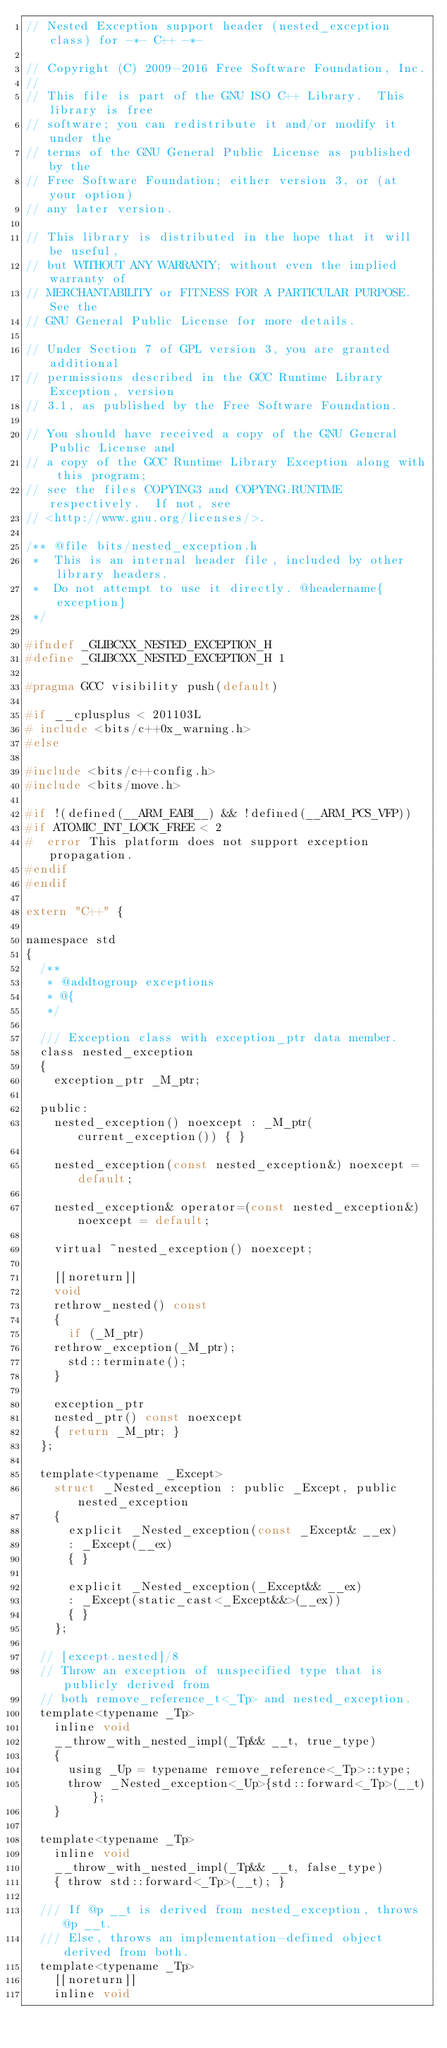<code> <loc_0><loc_0><loc_500><loc_500><_C_>// Nested Exception support header (nested_exception class) for -*- C++ -*-

// Copyright (C) 2009-2016 Free Software Foundation, Inc.
//
// This file is part of the GNU ISO C++ Library.  This library is free
// software; you can redistribute it and/or modify it under the
// terms of the GNU General Public License as published by the
// Free Software Foundation; either version 3, or (at your option)
// any later version.

// This library is distributed in the hope that it will be useful,
// but WITHOUT ANY WARRANTY; without even the implied warranty of
// MERCHANTABILITY or FITNESS FOR A PARTICULAR PURPOSE.  See the
// GNU General Public License for more details.

// Under Section 7 of GPL version 3, you are granted additional
// permissions described in the GCC Runtime Library Exception, version
// 3.1, as published by the Free Software Foundation.

// You should have received a copy of the GNU General Public License and
// a copy of the GCC Runtime Library Exception along with this program;
// see the files COPYING3 and COPYING.RUNTIME respectively.  If not, see
// <http://www.gnu.org/licenses/>.

/** @file bits/nested_exception.h
 *  This is an internal header file, included by other library headers.
 *  Do not attempt to use it directly. @headername{exception}
 */

#ifndef _GLIBCXX_NESTED_EXCEPTION_H
#define _GLIBCXX_NESTED_EXCEPTION_H 1

#pragma GCC visibility push(default)

#if __cplusplus < 201103L
# include <bits/c++0x_warning.h>
#else

#include <bits/c++config.h>
#include <bits/move.h>

#if !(defined(__ARM_EABI__) && !defined(__ARM_PCS_VFP))
#if ATOMIC_INT_LOCK_FREE < 2
#  error This platform does not support exception propagation.
#endif
#endif

extern "C++" {

namespace std
{
  /**
   * @addtogroup exceptions
   * @{
   */

  /// Exception class with exception_ptr data member.
  class nested_exception
  {
    exception_ptr _M_ptr;

  public:
    nested_exception() noexcept : _M_ptr(current_exception()) { }

    nested_exception(const nested_exception&) noexcept = default;

    nested_exception& operator=(const nested_exception&) noexcept = default;

    virtual ~nested_exception() noexcept;

    [[noreturn]]
    void
    rethrow_nested() const
    {
      if (_M_ptr)
	rethrow_exception(_M_ptr);
      std::terminate();
    }

    exception_ptr
    nested_ptr() const noexcept
    { return _M_ptr; }
  };

  template<typename _Except>
    struct _Nested_exception : public _Except, public nested_exception
    {
      explicit _Nested_exception(const _Except& __ex)
      : _Except(__ex)
      { }

      explicit _Nested_exception(_Except&& __ex)
      : _Except(static_cast<_Except&&>(__ex))
      { }
    };

  // [except.nested]/8
  // Throw an exception of unspecified type that is publicly derived from
  // both remove_reference_t<_Tp> and nested_exception.
  template<typename _Tp>
    inline void
    __throw_with_nested_impl(_Tp&& __t, true_type)
    {
      using _Up = typename remove_reference<_Tp>::type;
      throw _Nested_exception<_Up>{std::forward<_Tp>(__t)};
    }

  template<typename _Tp>
    inline void
    __throw_with_nested_impl(_Tp&& __t, false_type)
    { throw std::forward<_Tp>(__t); }

  /// If @p __t is derived from nested_exception, throws @p __t.
  /// Else, throws an implementation-defined object derived from both.
  template<typename _Tp>
    [[noreturn]]
    inline void</code> 